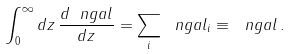<formula> <loc_0><loc_0><loc_500><loc_500>\int _ { 0 } ^ { \infty } d z \, \frac { d \ n g a l } { d z } = \sum _ { i } \ n g a l _ { i } \equiv \ n g a l \, .</formula> 